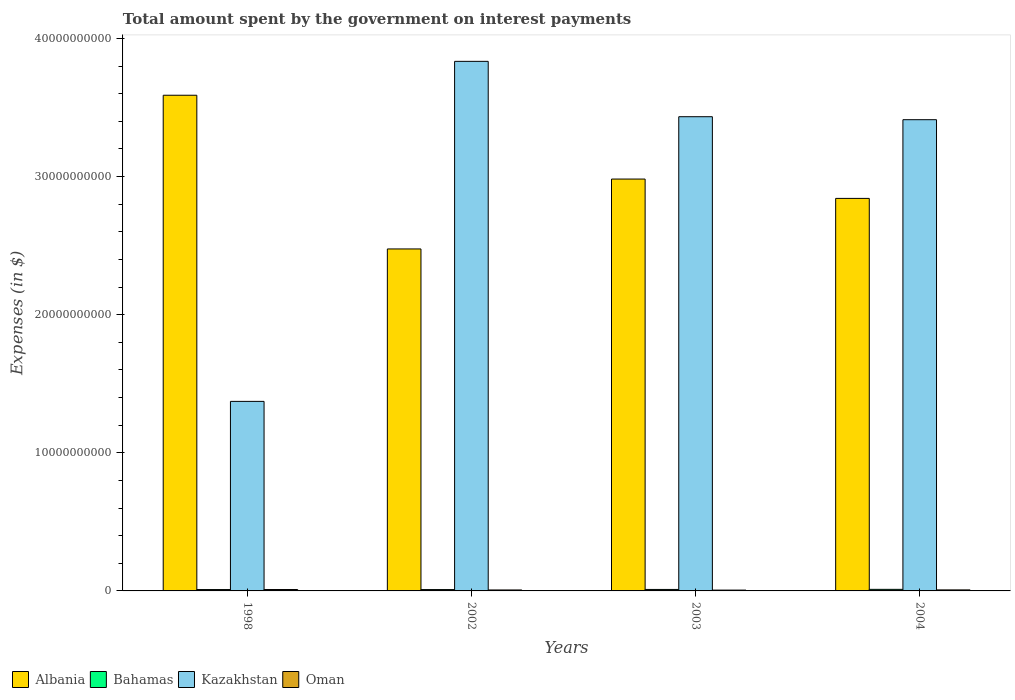How many different coloured bars are there?
Provide a succinct answer. 4. Are the number of bars per tick equal to the number of legend labels?
Offer a very short reply. Yes. How many bars are there on the 3rd tick from the right?
Your response must be concise. 4. What is the label of the 3rd group of bars from the left?
Give a very brief answer. 2003. In how many cases, is the number of bars for a given year not equal to the number of legend labels?
Make the answer very short. 0. What is the amount spent on interest payments by the government in Albania in 1998?
Provide a succinct answer. 3.59e+1. Across all years, what is the maximum amount spent on interest payments by the government in Bahamas?
Give a very brief answer. 1.14e+08. Across all years, what is the minimum amount spent on interest payments by the government in Oman?
Your response must be concise. 5.99e+07. In which year was the amount spent on interest payments by the government in Albania maximum?
Keep it short and to the point. 1998. What is the total amount spent on interest payments by the government in Oman in the graph?
Your answer should be compact. 3.06e+08. What is the difference between the amount spent on interest payments by the government in Bahamas in 2003 and that in 2004?
Provide a short and direct response. -6.94e+06. What is the difference between the amount spent on interest payments by the government in Oman in 2003 and the amount spent on interest payments by the government in Bahamas in 2002?
Ensure brevity in your answer.  -3.84e+07. What is the average amount spent on interest payments by the government in Albania per year?
Keep it short and to the point. 2.97e+1. In the year 2002, what is the difference between the amount spent on interest payments by the government in Kazakhstan and amount spent on interest payments by the government in Oman?
Provide a short and direct response. 3.83e+1. What is the ratio of the amount spent on interest payments by the government in Kazakhstan in 2003 to that in 2004?
Provide a succinct answer. 1.01. What is the difference between the highest and the second highest amount spent on interest payments by the government in Oman?
Your answer should be very brief. 2.72e+07. What is the difference between the highest and the lowest amount spent on interest payments by the government in Bahamas?
Provide a short and direct response. 1.56e+07. In how many years, is the amount spent on interest payments by the government in Kazakhstan greater than the average amount spent on interest payments by the government in Kazakhstan taken over all years?
Provide a succinct answer. 3. Is it the case that in every year, the sum of the amount spent on interest payments by the government in Albania and amount spent on interest payments by the government in Oman is greater than the sum of amount spent on interest payments by the government in Kazakhstan and amount spent on interest payments by the government in Bahamas?
Give a very brief answer. Yes. What does the 2nd bar from the left in 1998 represents?
Offer a very short reply. Bahamas. What does the 4th bar from the right in 2002 represents?
Give a very brief answer. Albania. Are the values on the major ticks of Y-axis written in scientific E-notation?
Your answer should be compact. No. Where does the legend appear in the graph?
Make the answer very short. Bottom left. How are the legend labels stacked?
Your answer should be very brief. Horizontal. What is the title of the graph?
Ensure brevity in your answer.  Total amount spent by the government on interest payments. Does "Nigeria" appear as one of the legend labels in the graph?
Make the answer very short. No. What is the label or title of the Y-axis?
Make the answer very short. Expenses (in $). What is the Expenses (in $) in Albania in 1998?
Your answer should be very brief. 3.59e+1. What is the Expenses (in $) in Bahamas in 1998?
Ensure brevity in your answer.  9.91e+07. What is the Expenses (in $) of Kazakhstan in 1998?
Give a very brief answer. 1.37e+1. What is the Expenses (in $) in Oman in 1998?
Keep it short and to the point. 1.02e+08. What is the Expenses (in $) of Albania in 2002?
Ensure brevity in your answer.  2.48e+1. What is the Expenses (in $) in Bahamas in 2002?
Your answer should be very brief. 9.83e+07. What is the Expenses (in $) of Kazakhstan in 2002?
Offer a terse response. 3.83e+1. What is the Expenses (in $) in Oman in 2002?
Provide a succinct answer. 6.98e+07. What is the Expenses (in $) in Albania in 2003?
Your response must be concise. 2.98e+1. What is the Expenses (in $) of Bahamas in 2003?
Keep it short and to the point. 1.07e+08. What is the Expenses (in $) in Kazakhstan in 2003?
Your answer should be compact. 3.43e+1. What is the Expenses (in $) in Oman in 2003?
Your response must be concise. 5.99e+07. What is the Expenses (in $) of Albania in 2004?
Provide a succinct answer. 2.84e+1. What is the Expenses (in $) of Bahamas in 2004?
Ensure brevity in your answer.  1.14e+08. What is the Expenses (in $) in Kazakhstan in 2004?
Make the answer very short. 3.41e+1. What is the Expenses (in $) of Oman in 2004?
Provide a short and direct response. 7.44e+07. Across all years, what is the maximum Expenses (in $) of Albania?
Provide a succinct answer. 3.59e+1. Across all years, what is the maximum Expenses (in $) in Bahamas?
Make the answer very short. 1.14e+08. Across all years, what is the maximum Expenses (in $) of Kazakhstan?
Offer a very short reply. 3.83e+1. Across all years, what is the maximum Expenses (in $) of Oman?
Offer a very short reply. 1.02e+08. Across all years, what is the minimum Expenses (in $) in Albania?
Your response must be concise. 2.48e+1. Across all years, what is the minimum Expenses (in $) in Bahamas?
Your response must be concise. 9.83e+07. Across all years, what is the minimum Expenses (in $) in Kazakhstan?
Your answer should be very brief. 1.37e+1. Across all years, what is the minimum Expenses (in $) of Oman?
Give a very brief answer. 5.99e+07. What is the total Expenses (in $) of Albania in the graph?
Provide a short and direct response. 1.19e+11. What is the total Expenses (in $) of Bahamas in the graph?
Ensure brevity in your answer.  4.18e+08. What is the total Expenses (in $) in Kazakhstan in the graph?
Your answer should be very brief. 1.21e+11. What is the total Expenses (in $) in Oman in the graph?
Your answer should be very brief. 3.06e+08. What is the difference between the Expenses (in $) of Albania in 1998 and that in 2002?
Your answer should be compact. 1.11e+1. What is the difference between the Expenses (in $) in Bahamas in 1998 and that in 2002?
Your response must be concise. 7.73e+05. What is the difference between the Expenses (in $) in Kazakhstan in 1998 and that in 2002?
Offer a very short reply. -2.46e+1. What is the difference between the Expenses (in $) of Oman in 1998 and that in 2002?
Your response must be concise. 3.18e+07. What is the difference between the Expenses (in $) of Albania in 1998 and that in 2003?
Your answer should be very brief. 6.07e+09. What is the difference between the Expenses (in $) of Bahamas in 1998 and that in 2003?
Offer a terse response. -7.93e+06. What is the difference between the Expenses (in $) in Kazakhstan in 1998 and that in 2003?
Keep it short and to the point. -2.06e+1. What is the difference between the Expenses (in $) in Oman in 1998 and that in 2003?
Offer a terse response. 4.17e+07. What is the difference between the Expenses (in $) of Albania in 1998 and that in 2004?
Provide a short and direct response. 7.47e+09. What is the difference between the Expenses (in $) in Bahamas in 1998 and that in 2004?
Keep it short and to the point. -1.49e+07. What is the difference between the Expenses (in $) in Kazakhstan in 1998 and that in 2004?
Provide a short and direct response. -2.04e+1. What is the difference between the Expenses (in $) of Oman in 1998 and that in 2004?
Give a very brief answer. 2.72e+07. What is the difference between the Expenses (in $) in Albania in 2002 and that in 2003?
Make the answer very short. -5.06e+09. What is the difference between the Expenses (in $) in Bahamas in 2002 and that in 2003?
Your answer should be compact. -8.70e+06. What is the difference between the Expenses (in $) in Kazakhstan in 2002 and that in 2003?
Offer a very short reply. 4.01e+09. What is the difference between the Expenses (in $) of Oman in 2002 and that in 2003?
Make the answer very short. 9.90e+06. What is the difference between the Expenses (in $) of Albania in 2002 and that in 2004?
Your response must be concise. -3.66e+09. What is the difference between the Expenses (in $) in Bahamas in 2002 and that in 2004?
Make the answer very short. -1.56e+07. What is the difference between the Expenses (in $) of Kazakhstan in 2002 and that in 2004?
Give a very brief answer. 4.23e+09. What is the difference between the Expenses (in $) in Oman in 2002 and that in 2004?
Ensure brevity in your answer.  -4.60e+06. What is the difference between the Expenses (in $) in Albania in 2003 and that in 2004?
Your answer should be very brief. 1.40e+09. What is the difference between the Expenses (in $) of Bahamas in 2003 and that in 2004?
Offer a very short reply. -6.94e+06. What is the difference between the Expenses (in $) of Kazakhstan in 2003 and that in 2004?
Your answer should be compact. 2.17e+08. What is the difference between the Expenses (in $) in Oman in 2003 and that in 2004?
Give a very brief answer. -1.45e+07. What is the difference between the Expenses (in $) in Albania in 1998 and the Expenses (in $) in Bahamas in 2002?
Ensure brevity in your answer.  3.58e+1. What is the difference between the Expenses (in $) in Albania in 1998 and the Expenses (in $) in Kazakhstan in 2002?
Keep it short and to the point. -2.45e+09. What is the difference between the Expenses (in $) in Albania in 1998 and the Expenses (in $) in Oman in 2002?
Give a very brief answer. 3.58e+1. What is the difference between the Expenses (in $) of Bahamas in 1998 and the Expenses (in $) of Kazakhstan in 2002?
Ensure brevity in your answer.  -3.82e+1. What is the difference between the Expenses (in $) in Bahamas in 1998 and the Expenses (in $) in Oman in 2002?
Ensure brevity in your answer.  2.93e+07. What is the difference between the Expenses (in $) in Kazakhstan in 1998 and the Expenses (in $) in Oman in 2002?
Your answer should be very brief. 1.37e+1. What is the difference between the Expenses (in $) in Albania in 1998 and the Expenses (in $) in Bahamas in 2003?
Your answer should be very brief. 3.58e+1. What is the difference between the Expenses (in $) of Albania in 1998 and the Expenses (in $) of Kazakhstan in 2003?
Offer a very short reply. 1.55e+09. What is the difference between the Expenses (in $) in Albania in 1998 and the Expenses (in $) in Oman in 2003?
Offer a very short reply. 3.58e+1. What is the difference between the Expenses (in $) in Bahamas in 1998 and the Expenses (in $) in Kazakhstan in 2003?
Give a very brief answer. -3.42e+1. What is the difference between the Expenses (in $) of Bahamas in 1998 and the Expenses (in $) of Oman in 2003?
Provide a succinct answer. 3.92e+07. What is the difference between the Expenses (in $) in Kazakhstan in 1998 and the Expenses (in $) in Oman in 2003?
Your answer should be compact. 1.37e+1. What is the difference between the Expenses (in $) of Albania in 1998 and the Expenses (in $) of Bahamas in 2004?
Give a very brief answer. 3.58e+1. What is the difference between the Expenses (in $) of Albania in 1998 and the Expenses (in $) of Kazakhstan in 2004?
Provide a succinct answer. 1.77e+09. What is the difference between the Expenses (in $) of Albania in 1998 and the Expenses (in $) of Oman in 2004?
Give a very brief answer. 3.58e+1. What is the difference between the Expenses (in $) of Bahamas in 1998 and the Expenses (in $) of Kazakhstan in 2004?
Provide a short and direct response. -3.40e+1. What is the difference between the Expenses (in $) in Bahamas in 1998 and the Expenses (in $) in Oman in 2004?
Offer a terse response. 2.47e+07. What is the difference between the Expenses (in $) in Kazakhstan in 1998 and the Expenses (in $) in Oman in 2004?
Offer a terse response. 1.37e+1. What is the difference between the Expenses (in $) in Albania in 2002 and the Expenses (in $) in Bahamas in 2003?
Provide a succinct answer. 2.47e+1. What is the difference between the Expenses (in $) in Albania in 2002 and the Expenses (in $) in Kazakhstan in 2003?
Make the answer very short. -9.58e+09. What is the difference between the Expenses (in $) of Albania in 2002 and the Expenses (in $) of Oman in 2003?
Provide a short and direct response. 2.47e+1. What is the difference between the Expenses (in $) of Bahamas in 2002 and the Expenses (in $) of Kazakhstan in 2003?
Give a very brief answer. -3.42e+1. What is the difference between the Expenses (in $) of Bahamas in 2002 and the Expenses (in $) of Oman in 2003?
Make the answer very short. 3.84e+07. What is the difference between the Expenses (in $) of Kazakhstan in 2002 and the Expenses (in $) of Oman in 2003?
Keep it short and to the point. 3.83e+1. What is the difference between the Expenses (in $) in Albania in 2002 and the Expenses (in $) in Bahamas in 2004?
Give a very brief answer. 2.46e+1. What is the difference between the Expenses (in $) in Albania in 2002 and the Expenses (in $) in Kazakhstan in 2004?
Make the answer very short. -9.36e+09. What is the difference between the Expenses (in $) of Albania in 2002 and the Expenses (in $) of Oman in 2004?
Your answer should be compact. 2.47e+1. What is the difference between the Expenses (in $) of Bahamas in 2002 and the Expenses (in $) of Kazakhstan in 2004?
Your response must be concise. -3.40e+1. What is the difference between the Expenses (in $) in Bahamas in 2002 and the Expenses (in $) in Oman in 2004?
Make the answer very short. 2.39e+07. What is the difference between the Expenses (in $) of Kazakhstan in 2002 and the Expenses (in $) of Oman in 2004?
Offer a very short reply. 3.83e+1. What is the difference between the Expenses (in $) of Albania in 2003 and the Expenses (in $) of Bahamas in 2004?
Provide a succinct answer. 2.97e+1. What is the difference between the Expenses (in $) in Albania in 2003 and the Expenses (in $) in Kazakhstan in 2004?
Ensure brevity in your answer.  -4.30e+09. What is the difference between the Expenses (in $) in Albania in 2003 and the Expenses (in $) in Oman in 2004?
Your answer should be very brief. 2.97e+1. What is the difference between the Expenses (in $) in Bahamas in 2003 and the Expenses (in $) in Kazakhstan in 2004?
Keep it short and to the point. -3.40e+1. What is the difference between the Expenses (in $) of Bahamas in 2003 and the Expenses (in $) of Oman in 2004?
Offer a very short reply. 3.26e+07. What is the difference between the Expenses (in $) of Kazakhstan in 2003 and the Expenses (in $) of Oman in 2004?
Ensure brevity in your answer.  3.43e+1. What is the average Expenses (in $) in Albania per year?
Provide a short and direct response. 2.97e+1. What is the average Expenses (in $) of Bahamas per year?
Provide a short and direct response. 1.05e+08. What is the average Expenses (in $) in Kazakhstan per year?
Your answer should be very brief. 3.01e+1. What is the average Expenses (in $) of Oman per year?
Your response must be concise. 7.64e+07. In the year 1998, what is the difference between the Expenses (in $) in Albania and Expenses (in $) in Bahamas?
Keep it short and to the point. 3.58e+1. In the year 1998, what is the difference between the Expenses (in $) in Albania and Expenses (in $) in Kazakhstan?
Your response must be concise. 2.22e+1. In the year 1998, what is the difference between the Expenses (in $) in Albania and Expenses (in $) in Oman?
Make the answer very short. 3.58e+1. In the year 1998, what is the difference between the Expenses (in $) in Bahamas and Expenses (in $) in Kazakhstan?
Ensure brevity in your answer.  -1.36e+1. In the year 1998, what is the difference between the Expenses (in $) in Bahamas and Expenses (in $) in Oman?
Your answer should be compact. -2.53e+06. In the year 1998, what is the difference between the Expenses (in $) of Kazakhstan and Expenses (in $) of Oman?
Ensure brevity in your answer.  1.36e+1. In the year 2002, what is the difference between the Expenses (in $) of Albania and Expenses (in $) of Bahamas?
Ensure brevity in your answer.  2.47e+1. In the year 2002, what is the difference between the Expenses (in $) in Albania and Expenses (in $) in Kazakhstan?
Offer a terse response. -1.36e+1. In the year 2002, what is the difference between the Expenses (in $) of Albania and Expenses (in $) of Oman?
Offer a very short reply. 2.47e+1. In the year 2002, what is the difference between the Expenses (in $) of Bahamas and Expenses (in $) of Kazakhstan?
Offer a very short reply. -3.82e+1. In the year 2002, what is the difference between the Expenses (in $) in Bahamas and Expenses (in $) in Oman?
Your answer should be very brief. 2.85e+07. In the year 2002, what is the difference between the Expenses (in $) in Kazakhstan and Expenses (in $) in Oman?
Your response must be concise. 3.83e+1. In the year 2003, what is the difference between the Expenses (in $) in Albania and Expenses (in $) in Bahamas?
Provide a short and direct response. 2.97e+1. In the year 2003, what is the difference between the Expenses (in $) in Albania and Expenses (in $) in Kazakhstan?
Offer a terse response. -4.51e+09. In the year 2003, what is the difference between the Expenses (in $) in Albania and Expenses (in $) in Oman?
Provide a succinct answer. 2.98e+1. In the year 2003, what is the difference between the Expenses (in $) of Bahamas and Expenses (in $) of Kazakhstan?
Provide a short and direct response. -3.42e+1. In the year 2003, what is the difference between the Expenses (in $) in Bahamas and Expenses (in $) in Oman?
Your response must be concise. 4.71e+07. In the year 2003, what is the difference between the Expenses (in $) in Kazakhstan and Expenses (in $) in Oman?
Give a very brief answer. 3.43e+1. In the year 2004, what is the difference between the Expenses (in $) of Albania and Expenses (in $) of Bahamas?
Your answer should be compact. 2.83e+1. In the year 2004, what is the difference between the Expenses (in $) in Albania and Expenses (in $) in Kazakhstan?
Provide a short and direct response. -5.70e+09. In the year 2004, what is the difference between the Expenses (in $) in Albania and Expenses (in $) in Oman?
Offer a very short reply. 2.83e+1. In the year 2004, what is the difference between the Expenses (in $) of Bahamas and Expenses (in $) of Kazakhstan?
Make the answer very short. -3.40e+1. In the year 2004, what is the difference between the Expenses (in $) of Bahamas and Expenses (in $) of Oman?
Your answer should be very brief. 3.95e+07. In the year 2004, what is the difference between the Expenses (in $) of Kazakhstan and Expenses (in $) of Oman?
Your answer should be compact. 3.40e+1. What is the ratio of the Expenses (in $) in Albania in 1998 to that in 2002?
Your response must be concise. 1.45. What is the ratio of the Expenses (in $) in Bahamas in 1998 to that in 2002?
Offer a terse response. 1.01. What is the ratio of the Expenses (in $) of Kazakhstan in 1998 to that in 2002?
Offer a terse response. 0.36. What is the ratio of the Expenses (in $) of Oman in 1998 to that in 2002?
Offer a very short reply. 1.46. What is the ratio of the Expenses (in $) in Albania in 1998 to that in 2003?
Make the answer very short. 1.2. What is the ratio of the Expenses (in $) in Bahamas in 1998 to that in 2003?
Provide a short and direct response. 0.93. What is the ratio of the Expenses (in $) in Kazakhstan in 1998 to that in 2003?
Your answer should be compact. 0.4. What is the ratio of the Expenses (in $) of Oman in 1998 to that in 2003?
Your answer should be compact. 1.7. What is the ratio of the Expenses (in $) of Albania in 1998 to that in 2004?
Make the answer very short. 1.26. What is the ratio of the Expenses (in $) in Bahamas in 1998 to that in 2004?
Your answer should be compact. 0.87. What is the ratio of the Expenses (in $) of Kazakhstan in 1998 to that in 2004?
Give a very brief answer. 0.4. What is the ratio of the Expenses (in $) in Oman in 1998 to that in 2004?
Your answer should be very brief. 1.37. What is the ratio of the Expenses (in $) in Albania in 2002 to that in 2003?
Your answer should be very brief. 0.83. What is the ratio of the Expenses (in $) of Bahamas in 2002 to that in 2003?
Offer a very short reply. 0.92. What is the ratio of the Expenses (in $) in Kazakhstan in 2002 to that in 2003?
Ensure brevity in your answer.  1.12. What is the ratio of the Expenses (in $) of Oman in 2002 to that in 2003?
Provide a short and direct response. 1.17. What is the ratio of the Expenses (in $) of Albania in 2002 to that in 2004?
Give a very brief answer. 0.87. What is the ratio of the Expenses (in $) of Bahamas in 2002 to that in 2004?
Keep it short and to the point. 0.86. What is the ratio of the Expenses (in $) in Kazakhstan in 2002 to that in 2004?
Keep it short and to the point. 1.12. What is the ratio of the Expenses (in $) of Oman in 2002 to that in 2004?
Make the answer very short. 0.94. What is the ratio of the Expenses (in $) in Albania in 2003 to that in 2004?
Ensure brevity in your answer.  1.05. What is the ratio of the Expenses (in $) in Bahamas in 2003 to that in 2004?
Give a very brief answer. 0.94. What is the ratio of the Expenses (in $) in Kazakhstan in 2003 to that in 2004?
Your answer should be very brief. 1.01. What is the ratio of the Expenses (in $) in Oman in 2003 to that in 2004?
Your answer should be very brief. 0.81. What is the difference between the highest and the second highest Expenses (in $) in Albania?
Provide a succinct answer. 6.07e+09. What is the difference between the highest and the second highest Expenses (in $) of Bahamas?
Offer a very short reply. 6.94e+06. What is the difference between the highest and the second highest Expenses (in $) of Kazakhstan?
Keep it short and to the point. 4.01e+09. What is the difference between the highest and the second highest Expenses (in $) of Oman?
Offer a very short reply. 2.72e+07. What is the difference between the highest and the lowest Expenses (in $) of Albania?
Your answer should be very brief. 1.11e+1. What is the difference between the highest and the lowest Expenses (in $) in Bahamas?
Ensure brevity in your answer.  1.56e+07. What is the difference between the highest and the lowest Expenses (in $) in Kazakhstan?
Make the answer very short. 2.46e+1. What is the difference between the highest and the lowest Expenses (in $) in Oman?
Ensure brevity in your answer.  4.17e+07. 